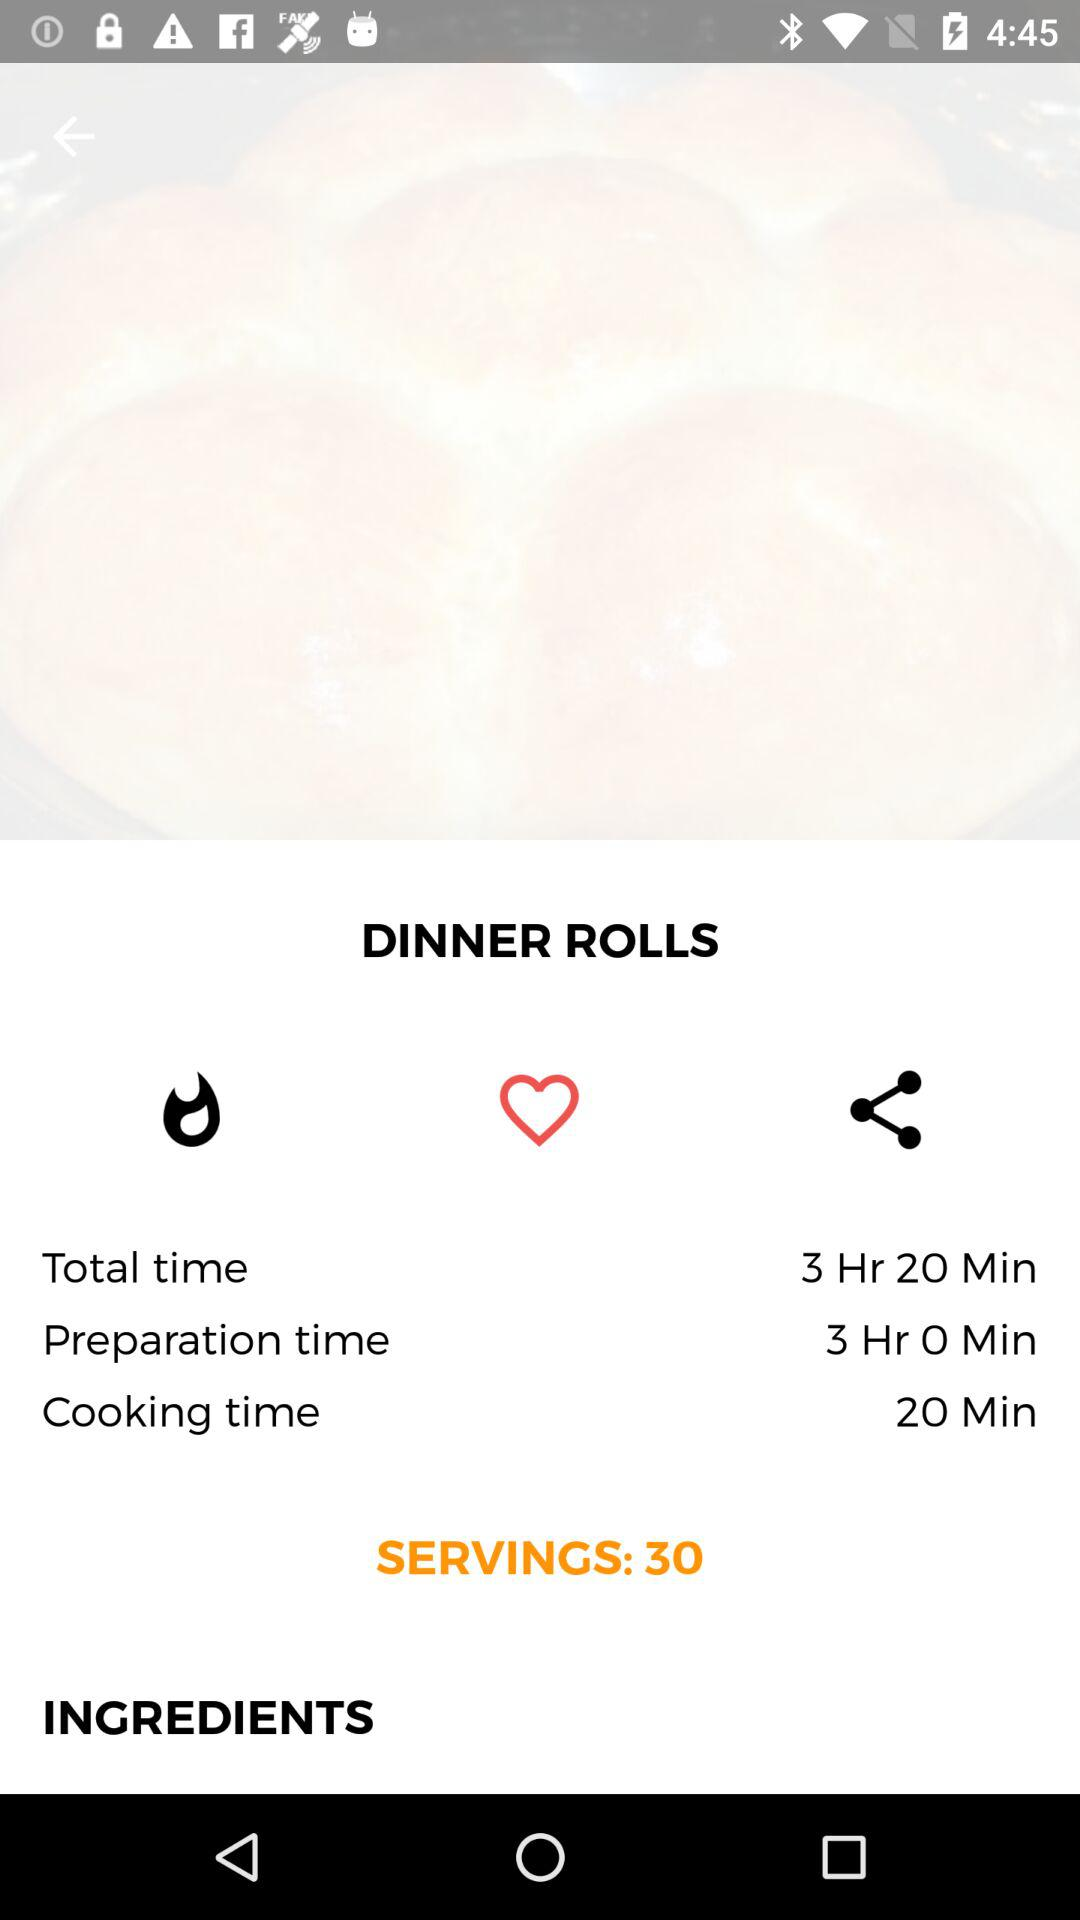How long do dinner rolls take to cook? Dinner rolls take 20 minutes to cook. 